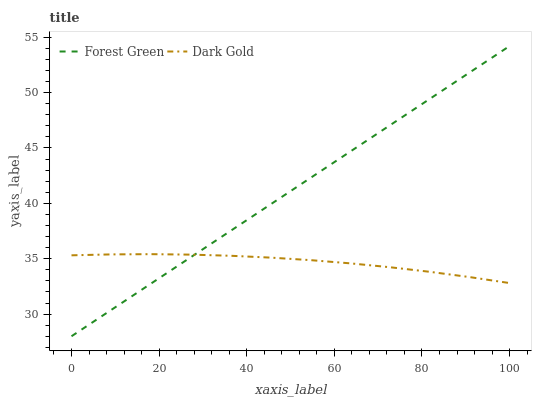Does Dark Gold have the minimum area under the curve?
Answer yes or no. Yes. Does Forest Green have the maximum area under the curve?
Answer yes or no. Yes. Does Dark Gold have the maximum area under the curve?
Answer yes or no. No. Is Forest Green the smoothest?
Answer yes or no. Yes. Is Dark Gold the roughest?
Answer yes or no. Yes. Is Dark Gold the smoothest?
Answer yes or no. No. Does Forest Green have the lowest value?
Answer yes or no. Yes. Does Dark Gold have the lowest value?
Answer yes or no. No. Does Forest Green have the highest value?
Answer yes or no. Yes. Does Dark Gold have the highest value?
Answer yes or no. No. Does Forest Green intersect Dark Gold?
Answer yes or no. Yes. Is Forest Green less than Dark Gold?
Answer yes or no. No. Is Forest Green greater than Dark Gold?
Answer yes or no. No. 